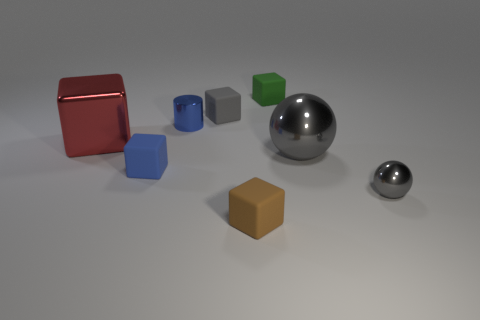How many cubes are the same color as the big sphere?
Give a very brief answer. 1. What number of objects are either big things in front of the metal cube or gray things behind the large metal sphere?
Offer a very short reply. 2. Is the number of tiny green matte objects right of the small gray metal sphere less than the number of small blue cylinders?
Provide a short and direct response. Yes. Is there another red metal object of the same size as the red metallic object?
Make the answer very short. No. The cylinder is what color?
Keep it short and to the point. Blue. Is the size of the brown matte thing the same as the red block?
Offer a very short reply. No. What number of objects are either gray matte objects or large cyan matte balls?
Provide a short and direct response. 1. Are there an equal number of blue rubber cubes that are behind the tiny green thing and tiny objects?
Give a very brief answer. No. There is a small metallic object on the left side of the metal object in front of the large gray thing; is there a green block that is to the left of it?
Your answer should be very brief. No. There is another sphere that is the same material as the small gray ball; what color is it?
Give a very brief answer. Gray. 